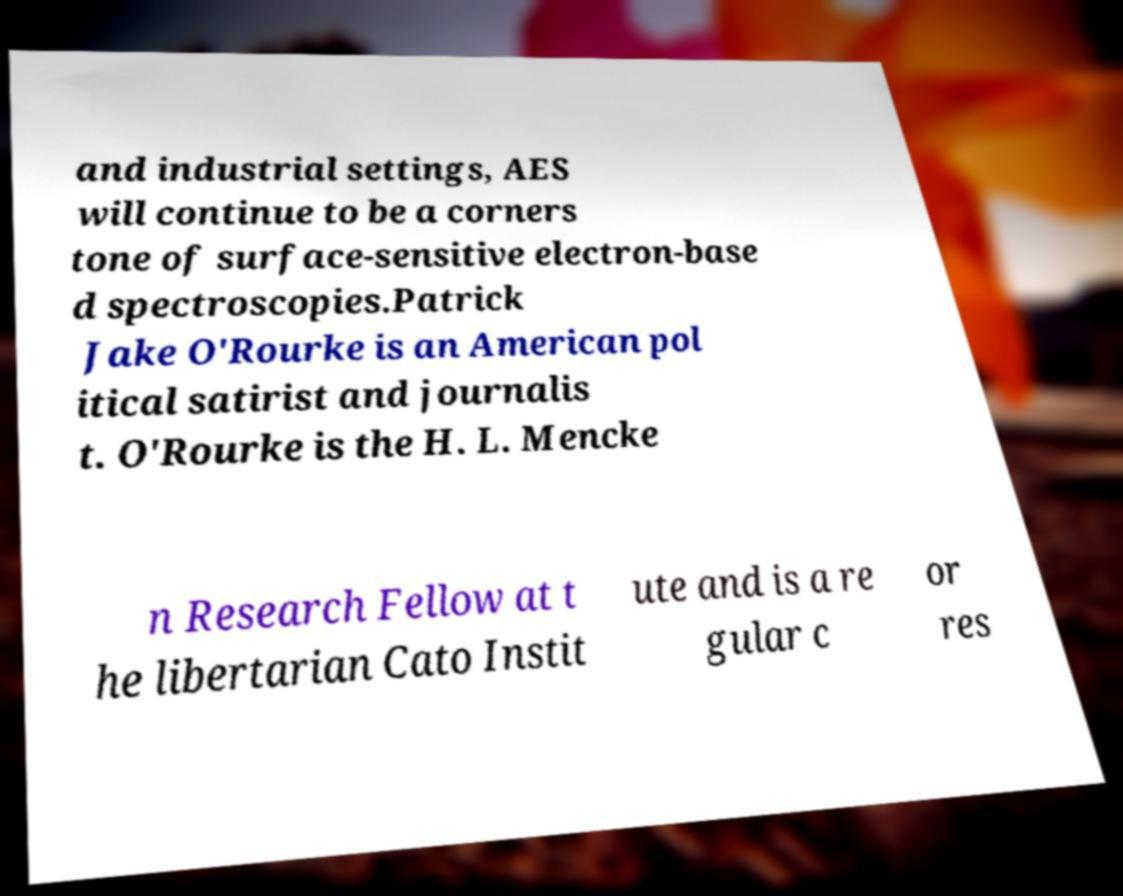Could you extract and type out the text from this image? and industrial settings, AES will continue to be a corners tone of surface-sensitive electron-base d spectroscopies.Patrick Jake O'Rourke is an American pol itical satirist and journalis t. O'Rourke is the H. L. Mencke n Research Fellow at t he libertarian Cato Instit ute and is a re gular c or res 